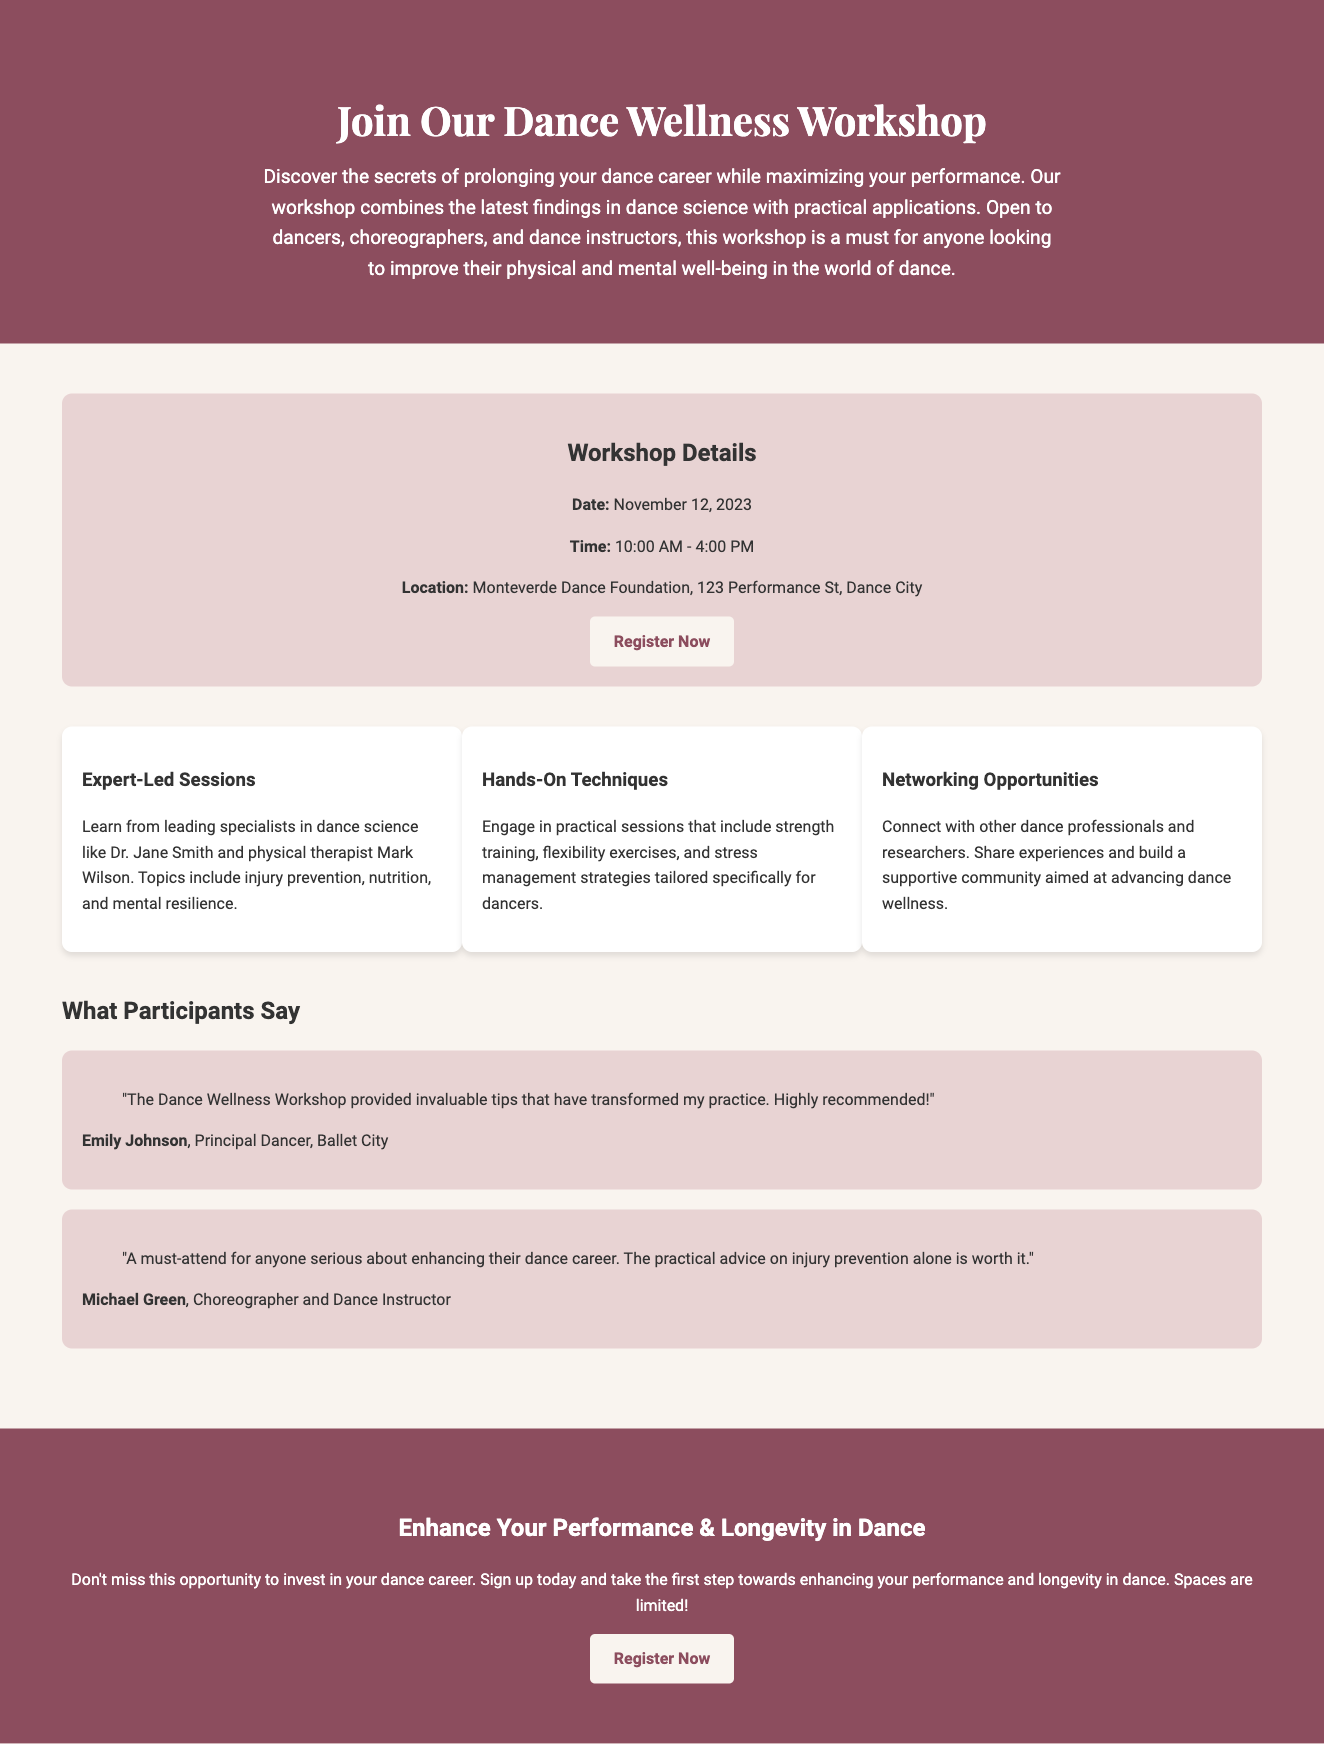What is the date of the workshop? The workshop is scheduled for November 12, 2023, as stated in the workshop details.
Answer: November 12, 2023 Who are the experts leading the sessions? The document mentions Dr. Jane Smith and Mark Wilson as leading specialists in dance science.
Answer: Dr. Jane Smith and Mark Wilson What is the main focus of the workshop? The overview indicates that the workshop focuses on prolonging dance careers and maximizing performance.
Answer: Enhancing performance and longevity What time does the workshop start? According to the workshop details, the workshop starts at 10:00 AM.
Answer: 10:00 AM What is one feature of the workshop? The document lists Expert-Led Sessions, Hands-On Techniques, and Networking Opportunities as features of the workshop.
Answer: Expert-Led Sessions How long is the workshop scheduled to last? The document states that the workshop runs from 10:00 AM to 4:00 PM, implying a duration of 6 hours.
Answer: 6 hours What is one participant's testimonial? Emily Johnson shares a testimonial about invaluable tips that transformed her practice, emphasizing recommended experiences.
Answer: "The Dance Wellness Workshop provided invaluable tips that have transformed my practice." Where is the workshop located? The location of the workshop is given as Monteverde Dance Foundation, 123 Performance St, Dance City.
Answer: Monteverde Dance Foundation, 123 Performance St, Dance City What opportunities does the workshop provide for attendees? The document mentions networking opportunities to connect with other dance professionals and researchers.
Answer: Networking Opportunities 